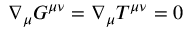<formula> <loc_0><loc_0><loc_500><loc_500>\nabla _ { \mu } G ^ { \mu \nu } = \nabla _ { \mu } T ^ { \mu \nu } = 0</formula> 